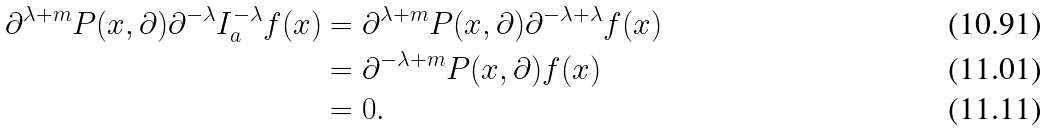Convert formula to latex. <formula><loc_0><loc_0><loc_500><loc_500>\partial ^ { \lambda + m } P ( x , \partial ) \partial ^ { - \lambda } I _ { a } ^ { - \lambda } f ( x ) & = \partial ^ { \lambda + m } P ( x , \partial ) \partial ^ { - \lambda + \lambda } f ( x ) \\ & = \partial ^ { - \lambda + m } P ( x , \partial ) f ( x ) \\ & = 0 .</formula> 